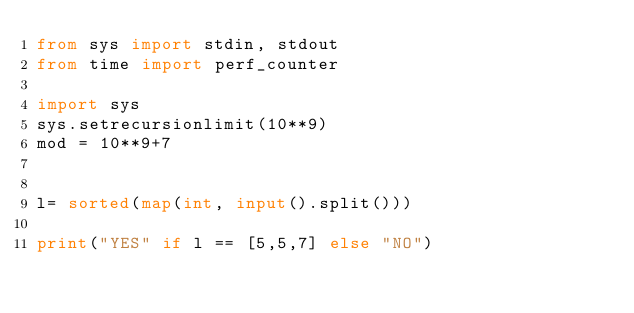<code> <loc_0><loc_0><loc_500><loc_500><_Python_>from sys import stdin, stdout
from time import perf_counter

import sys
sys.setrecursionlimit(10**9)
mod = 10**9+7


l= sorted(map(int, input().split()))

print("YES" if l == [5,5,7] else "NO")</code> 